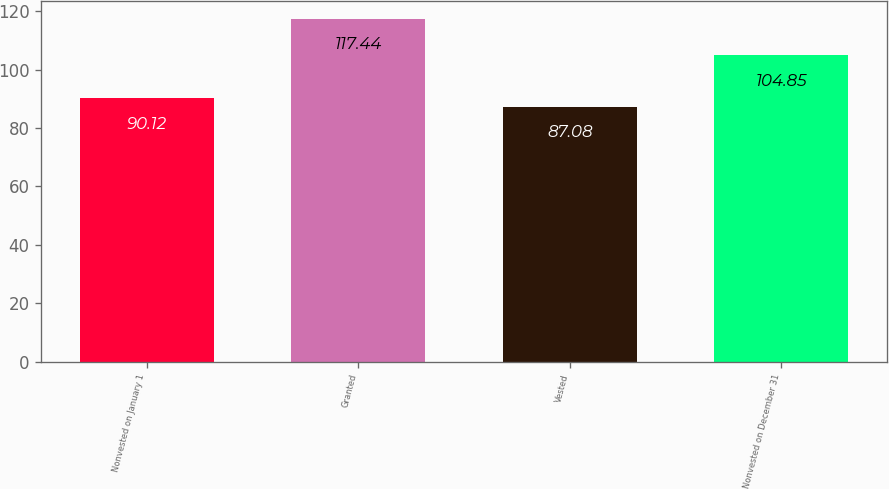Convert chart. <chart><loc_0><loc_0><loc_500><loc_500><bar_chart><fcel>Nonvested on January 1<fcel>Granted<fcel>Vested<fcel>Nonvested on December 31<nl><fcel>90.12<fcel>117.44<fcel>87.08<fcel>104.85<nl></chart> 